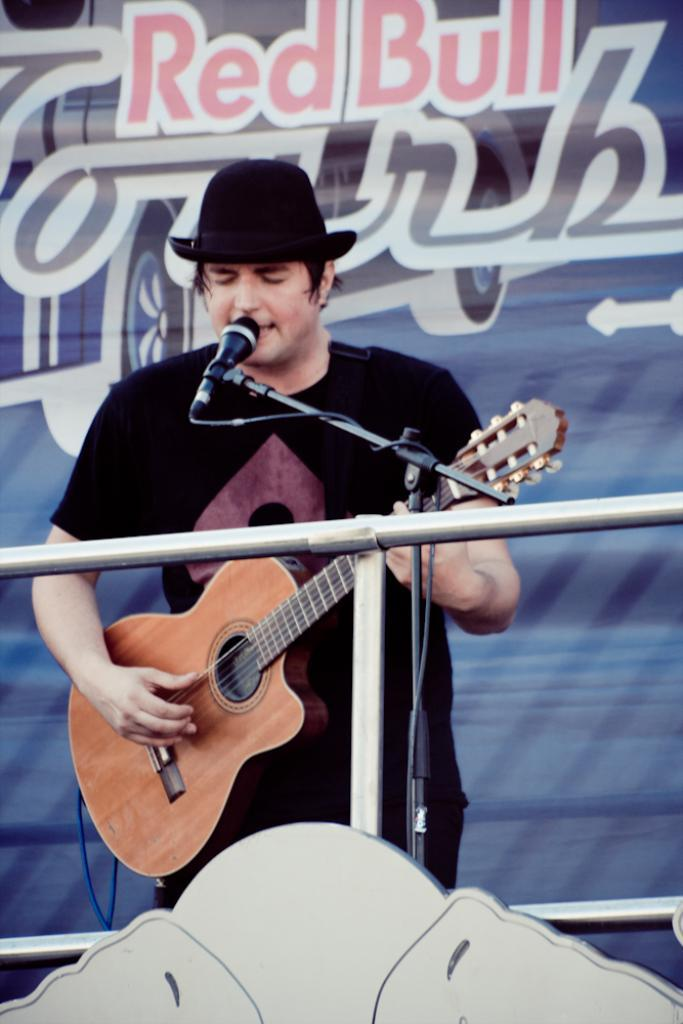What is the man in the picture doing? The man is playing the guitar and singing. What instrument is the man playing in the picture? The man is playing the guitar. What type of butter is the man using to play the guitar in the image? There is no butter present in the image, and the man is not using any butter to play the guitar. 